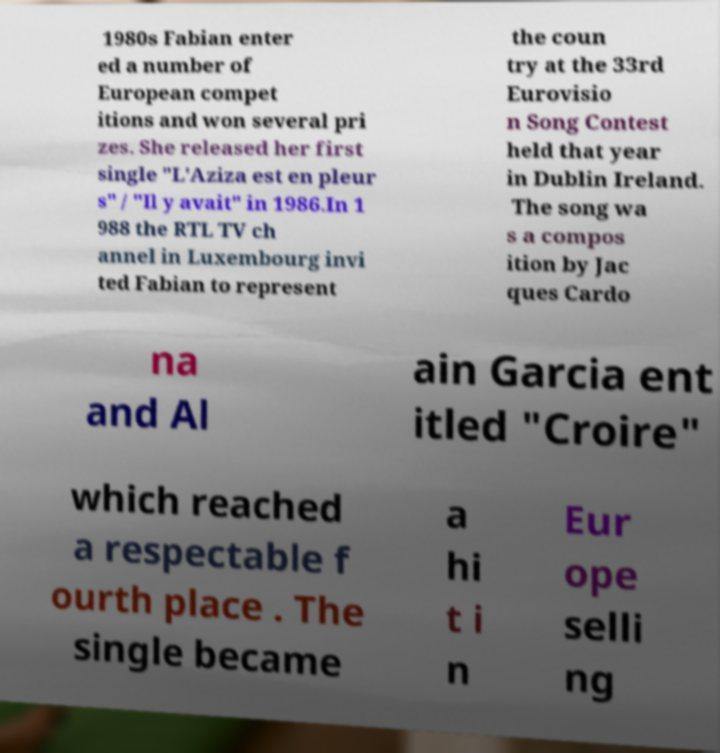For documentation purposes, I need the text within this image transcribed. Could you provide that? 1980s Fabian enter ed a number of European compet itions and won several pri zes. She released her first single "L'Aziza est en pleur s" / "Il y avait" in 1986.In 1 988 the RTL TV ch annel in Luxembourg invi ted Fabian to represent the coun try at the 33rd Eurovisio n Song Contest held that year in Dublin Ireland. The song wa s a compos ition by Jac ques Cardo na and Al ain Garcia ent itled "Croire" which reached a respectable f ourth place . The single became a hi t i n Eur ope selli ng 